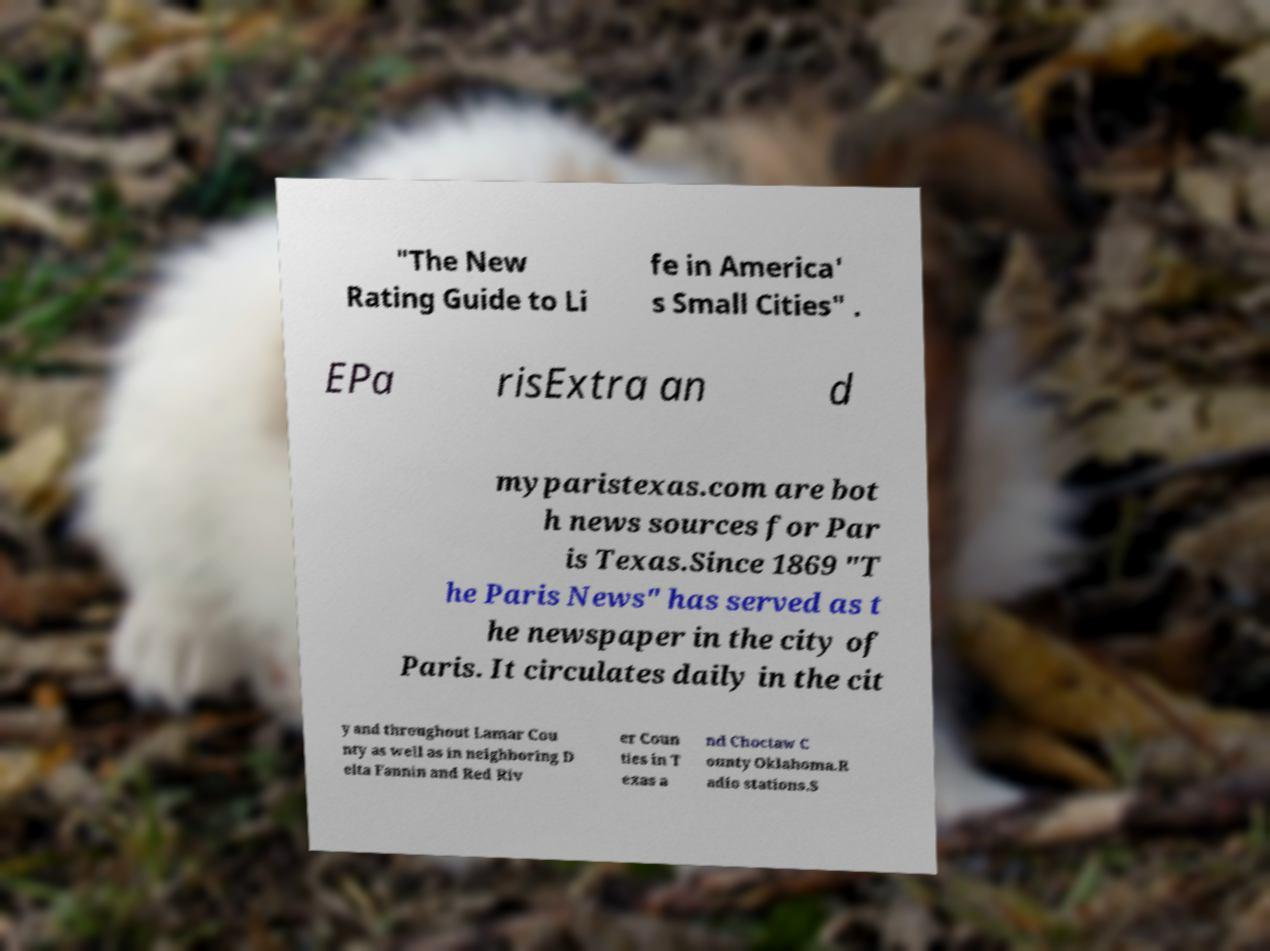For documentation purposes, I need the text within this image transcribed. Could you provide that? "The New Rating Guide to Li fe in America' s Small Cities" . EPa risExtra an d myparistexas.com are bot h news sources for Par is Texas.Since 1869 "T he Paris News" has served as t he newspaper in the city of Paris. It circulates daily in the cit y and throughout Lamar Cou nty as well as in neighboring D elta Fannin and Red Riv er Coun ties in T exas a nd Choctaw C ounty Oklahoma.R adio stations.S 